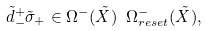Convert formula to latex. <formula><loc_0><loc_0><loc_500><loc_500>\tilde { d } _ { - } ^ { + } \tilde { \sigma } _ { + } \in \Omega ^ { - } ( \tilde { X } ) \ \Omega ^ { - } _ { r e s e t } ( \tilde { X } ) ,</formula> 